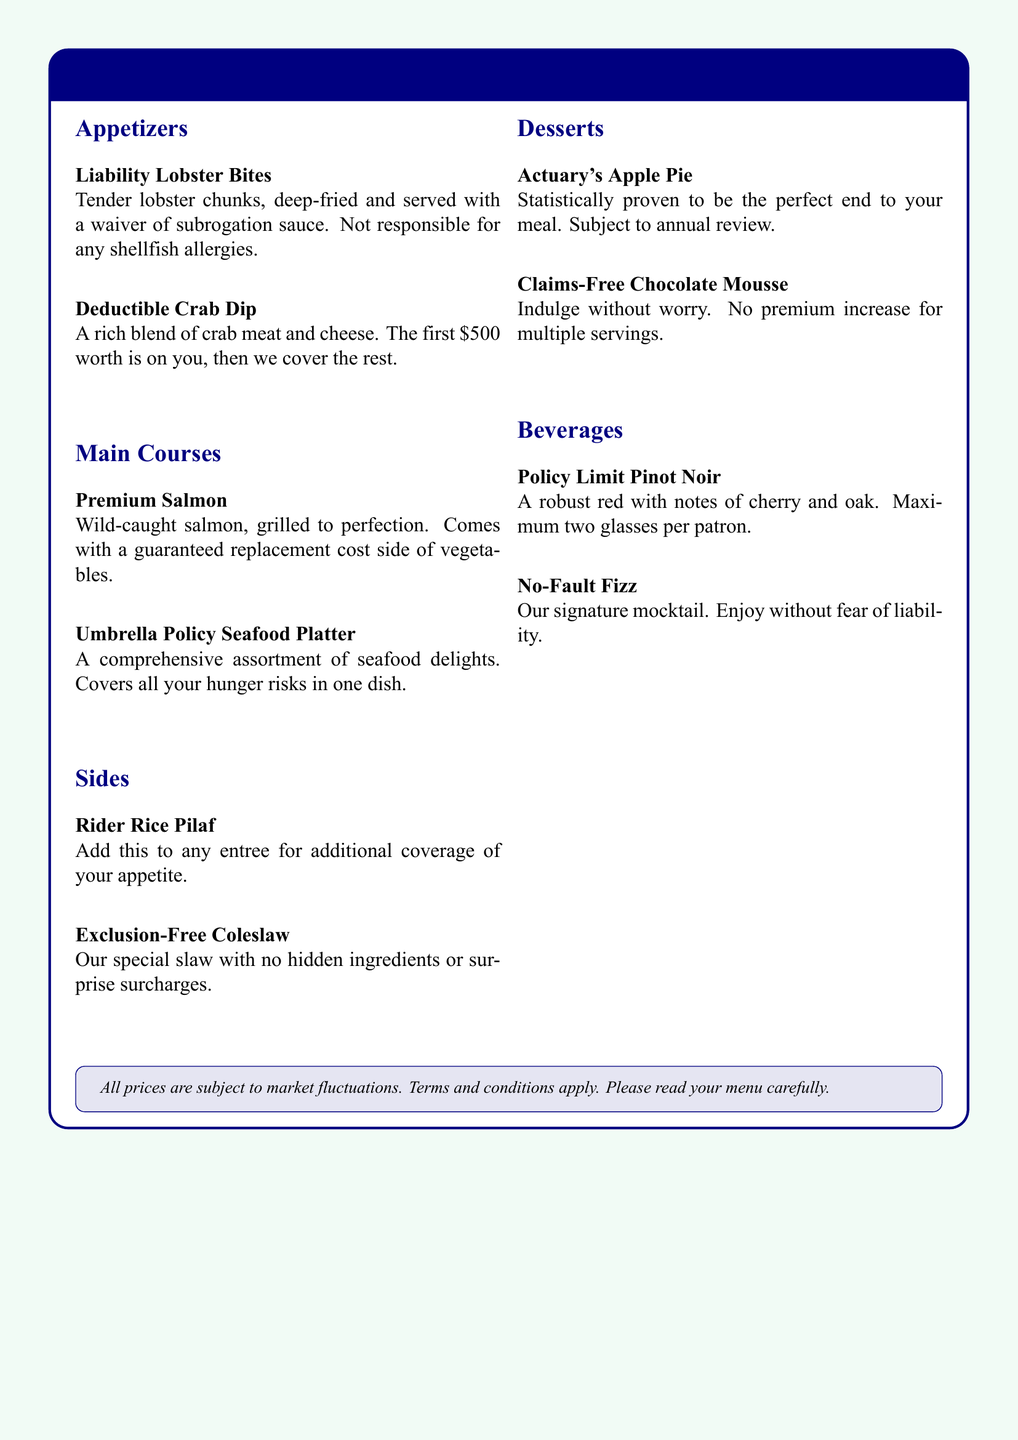What are the appetizers listed? The appetizers listed include Liability Lobster Bites and Deductible Crab Dip.
Answer: Liability Lobster Bites, Deductible Crab Dip What is the price coverage for the Deductible Crab Dip? The price coverage for the Deductible Crab Dip states the first $500 worth is on you.
Answer: $500 What is included in the Umbrella Policy Seafood Platter? The Umbrella Policy Seafood Platter includes a comprehensive assortment of seafood delights.
Answer: Comprehensive assortment of seafood delights What dessert is statistically proven to be the perfect end? The dessert that is statistically proven to be the perfect end is Actuary's Apple Pie.
Answer: Actuary's Apple Pie How many glasses of Policy Limit Pinot Noir can a patron have? The Policy Limit Pinot Noir states a maximum of two glasses per patron.
Answer: Two glasses What is served with the Premium Salmon? The Premium Salmon comes with a guaranteed replacement cost side of vegetables.
Answer: Guaranteed replacement cost side of vegetables What does the Exclusion-Free Coleslaw promise? The Exclusion-Free Coleslaw promises no hidden ingredients or surprise surcharges.
Answer: No hidden ingredients or surprise surcharges What type of drink is No-Fault Fizz? The No-Fault Fizz is described as a signature mocktail.
Answer: Signature mocktail What appetizers are deep-fried? The appetizer that is deep-fried is Liability Lobster Bites.
Answer: Liability Lobster Bites 